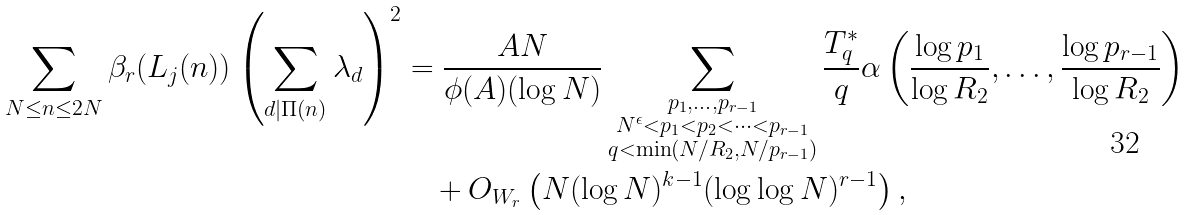Convert formula to latex. <formula><loc_0><loc_0><loc_500><loc_500>\sum _ { N \leq n \leq 2 N } \beta _ { r } ( L _ { j } ( n ) ) \left ( \sum _ { d | \Pi ( n ) } \lambda _ { d } \right ) ^ { 2 } & = \frac { A N } { \phi ( A ) ( \log { N } ) } \sum _ { \substack { p _ { 1 } , \dots , p _ { r - 1 } \\ N ^ { \epsilon } < p _ { 1 } < p _ { 2 } < \dots < p _ { r - 1 } \\ q < \min ( N / R _ { 2 } , N / p _ { r - 1 } ) } } \frac { T ^ { * } _ { q } } { q } \alpha \left ( \frac { \log { p _ { 1 } } } { \log { R _ { 2 } } } , \dots , \frac { \log { p _ { r - 1 } } } { \log { R _ { 2 } } } \right ) \\ & \quad + O _ { W _ { r } } \left ( N ( \log { N } ) ^ { k - 1 } ( \log \log { N } ) ^ { r - 1 } \right ) ,</formula> 